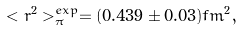Convert formula to latex. <formula><loc_0><loc_0><loc_500><loc_500>< r ^ { 2 } > _ { \pi } ^ { e x p } = ( 0 . 4 3 9 \pm 0 . 0 3 ) f m ^ { 2 } ,</formula> 